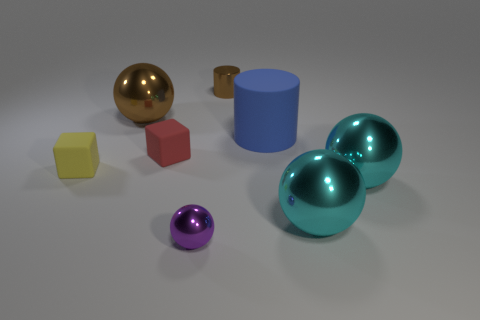Add 2 purple spheres. How many objects exist? 10 Subtract all cylinders. How many objects are left? 6 Add 6 small purple things. How many small purple things are left? 7 Add 5 big gray shiny cylinders. How many big gray shiny cylinders exist? 5 Subtract 1 brown cylinders. How many objects are left? 7 Subtract all big gray blocks. Subtract all tiny brown shiny cylinders. How many objects are left? 7 